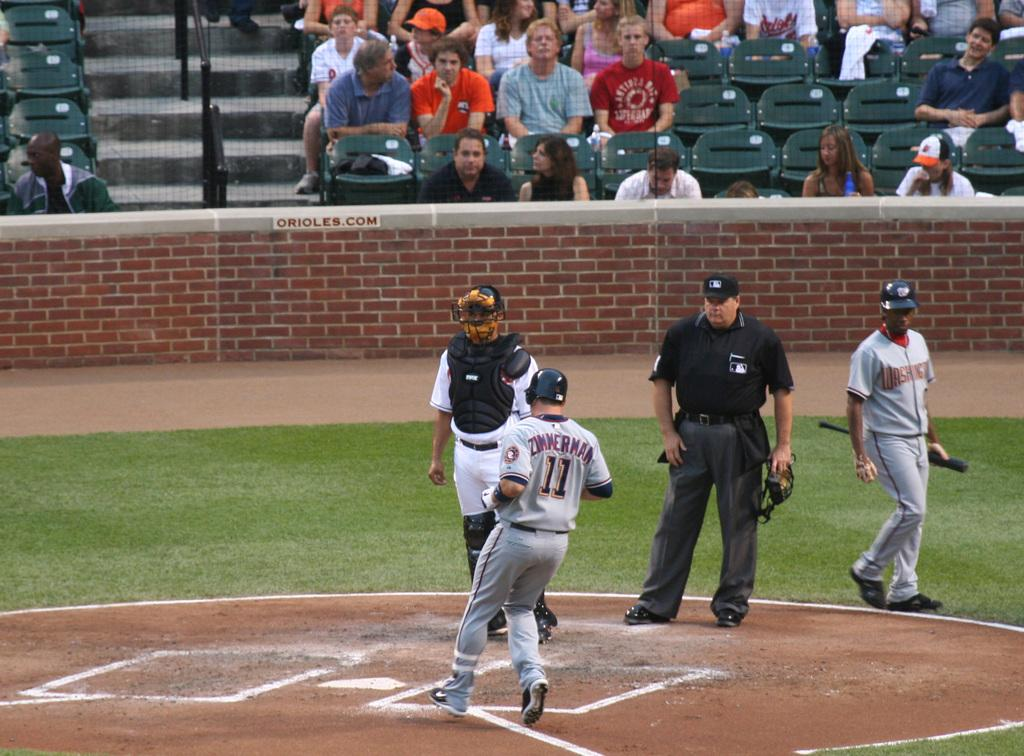Provide a one-sentence caption for the provided image. Number 11 is approaching home plate as the catcher looks on. 